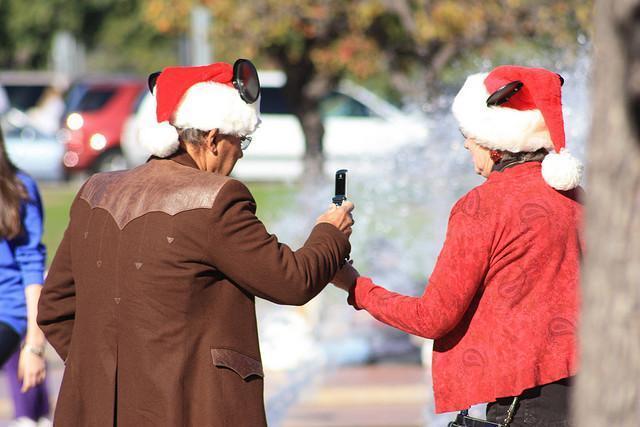How many people are there?
Give a very brief answer. 3. How many cars can you see?
Give a very brief answer. 4. 